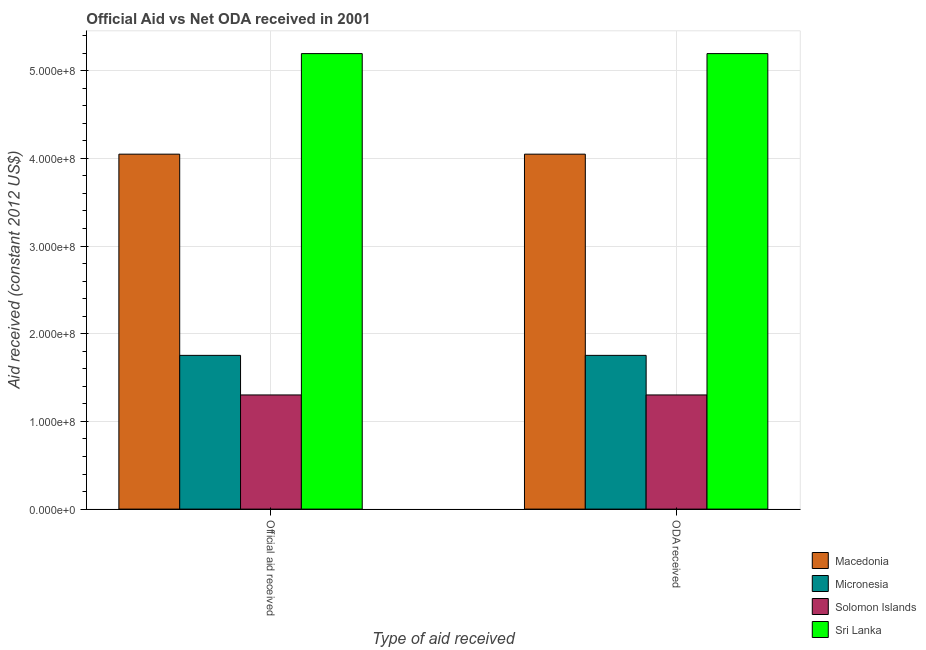How many groups of bars are there?
Your answer should be compact. 2. Are the number of bars per tick equal to the number of legend labels?
Provide a succinct answer. Yes. How many bars are there on the 2nd tick from the left?
Give a very brief answer. 4. What is the label of the 1st group of bars from the left?
Your answer should be very brief. Official aid received. What is the oda received in Solomon Islands?
Make the answer very short. 1.30e+08. Across all countries, what is the maximum official aid received?
Ensure brevity in your answer.  5.20e+08. Across all countries, what is the minimum official aid received?
Ensure brevity in your answer.  1.30e+08. In which country was the oda received maximum?
Provide a short and direct response. Sri Lanka. In which country was the official aid received minimum?
Your response must be concise. Solomon Islands. What is the total oda received in the graph?
Ensure brevity in your answer.  1.23e+09. What is the difference between the official aid received in Solomon Islands and that in Micronesia?
Your response must be concise. -4.52e+07. What is the difference between the oda received in Micronesia and the official aid received in Sri Lanka?
Make the answer very short. -3.44e+08. What is the average oda received per country?
Keep it short and to the point. 3.07e+08. What is the difference between the official aid received and oda received in Micronesia?
Offer a very short reply. 0. In how many countries, is the official aid received greater than 400000000 US$?
Give a very brief answer. 2. What is the ratio of the oda received in Micronesia to that in Macedonia?
Make the answer very short. 0.43. In how many countries, is the official aid received greater than the average official aid received taken over all countries?
Keep it short and to the point. 2. What does the 3rd bar from the left in ODA received represents?
Keep it short and to the point. Solomon Islands. What does the 1st bar from the right in Official aid received represents?
Provide a short and direct response. Sri Lanka. Are all the bars in the graph horizontal?
Your response must be concise. No. How many countries are there in the graph?
Offer a very short reply. 4. What is the difference between two consecutive major ticks on the Y-axis?
Ensure brevity in your answer.  1.00e+08. Does the graph contain any zero values?
Keep it short and to the point. No. Does the graph contain grids?
Offer a terse response. Yes. How many legend labels are there?
Your answer should be very brief. 4. How are the legend labels stacked?
Your response must be concise. Vertical. What is the title of the graph?
Provide a succinct answer. Official Aid vs Net ODA received in 2001 . Does "Georgia" appear as one of the legend labels in the graph?
Give a very brief answer. No. What is the label or title of the X-axis?
Offer a terse response. Type of aid received. What is the label or title of the Y-axis?
Ensure brevity in your answer.  Aid received (constant 2012 US$). What is the Aid received (constant 2012 US$) in Macedonia in Official aid received?
Ensure brevity in your answer.  4.05e+08. What is the Aid received (constant 2012 US$) of Micronesia in Official aid received?
Offer a very short reply. 1.75e+08. What is the Aid received (constant 2012 US$) of Solomon Islands in Official aid received?
Keep it short and to the point. 1.30e+08. What is the Aid received (constant 2012 US$) in Sri Lanka in Official aid received?
Offer a terse response. 5.20e+08. What is the Aid received (constant 2012 US$) of Macedonia in ODA received?
Make the answer very short. 4.05e+08. What is the Aid received (constant 2012 US$) of Micronesia in ODA received?
Offer a terse response. 1.75e+08. What is the Aid received (constant 2012 US$) in Solomon Islands in ODA received?
Ensure brevity in your answer.  1.30e+08. What is the Aid received (constant 2012 US$) of Sri Lanka in ODA received?
Your answer should be very brief. 5.20e+08. Across all Type of aid received, what is the maximum Aid received (constant 2012 US$) in Macedonia?
Offer a very short reply. 4.05e+08. Across all Type of aid received, what is the maximum Aid received (constant 2012 US$) in Micronesia?
Your answer should be very brief. 1.75e+08. Across all Type of aid received, what is the maximum Aid received (constant 2012 US$) in Solomon Islands?
Make the answer very short. 1.30e+08. Across all Type of aid received, what is the maximum Aid received (constant 2012 US$) of Sri Lanka?
Offer a terse response. 5.20e+08. Across all Type of aid received, what is the minimum Aid received (constant 2012 US$) in Macedonia?
Make the answer very short. 4.05e+08. Across all Type of aid received, what is the minimum Aid received (constant 2012 US$) in Micronesia?
Your answer should be very brief. 1.75e+08. Across all Type of aid received, what is the minimum Aid received (constant 2012 US$) in Solomon Islands?
Make the answer very short. 1.30e+08. Across all Type of aid received, what is the minimum Aid received (constant 2012 US$) in Sri Lanka?
Give a very brief answer. 5.20e+08. What is the total Aid received (constant 2012 US$) of Macedonia in the graph?
Ensure brevity in your answer.  8.10e+08. What is the total Aid received (constant 2012 US$) in Micronesia in the graph?
Offer a terse response. 3.51e+08. What is the total Aid received (constant 2012 US$) in Solomon Islands in the graph?
Your answer should be compact. 2.60e+08. What is the total Aid received (constant 2012 US$) of Sri Lanka in the graph?
Ensure brevity in your answer.  1.04e+09. What is the difference between the Aid received (constant 2012 US$) of Micronesia in Official aid received and that in ODA received?
Keep it short and to the point. 0. What is the difference between the Aid received (constant 2012 US$) of Solomon Islands in Official aid received and that in ODA received?
Your response must be concise. 0. What is the difference between the Aid received (constant 2012 US$) of Macedonia in Official aid received and the Aid received (constant 2012 US$) of Micronesia in ODA received?
Ensure brevity in your answer.  2.29e+08. What is the difference between the Aid received (constant 2012 US$) of Macedonia in Official aid received and the Aid received (constant 2012 US$) of Solomon Islands in ODA received?
Offer a terse response. 2.75e+08. What is the difference between the Aid received (constant 2012 US$) in Macedonia in Official aid received and the Aid received (constant 2012 US$) in Sri Lanka in ODA received?
Keep it short and to the point. -1.15e+08. What is the difference between the Aid received (constant 2012 US$) in Micronesia in Official aid received and the Aid received (constant 2012 US$) in Solomon Islands in ODA received?
Your answer should be very brief. 4.52e+07. What is the difference between the Aid received (constant 2012 US$) in Micronesia in Official aid received and the Aid received (constant 2012 US$) in Sri Lanka in ODA received?
Your answer should be very brief. -3.44e+08. What is the difference between the Aid received (constant 2012 US$) of Solomon Islands in Official aid received and the Aid received (constant 2012 US$) of Sri Lanka in ODA received?
Your response must be concise. -3.89e+08. What is the average Aid received (constant 2012 US$) of Macedonia per Type of aid received?
Give a very brief answer. 4.05e+08. What is the average Aid received (constant 2012 US$) in Micronesia per Type of aid received?
Give a very brief answer. 1.75e+08. What is the average Aid received (constant 2012 US$) of Solomon Islands per Type of aid received?
Offer a very short reply. 1.30e+08. What is the average Aid received (constant 2012 US$) in Sri Lanka per Type of aid received?
Provide a short and direct response. 5.20e+08. What is the difference between the Aid received (constant 2012 US$) of Macedonia and Aid received (constant 2012 US$) of Micronesia in Official aid received?
Offer a very short reply. 2.29e+08. What is the difference between the Aid received (constant 2012 US$) of Macedonia and Aid received (constant 2012 US$) of Solomon Islands in Official aid received?
Offer a terse response. 2.75e+08. What is the difference between the Aid received (constant 2012 US$) in Macedonia and Aid received (constant 2012 US$) in Sri Lanka in Official aid received?
Offer a terse response. -1.15e+08. What is the difference between the Aid received (constant 2012 US$) of Micronesia and Aid received (constant 2012 US$) of Solomon Islands in Official aid received?
Offer a terse response. 4.52e+07. What is the difference between the Aid received (constant 2012 US$) in Micronesia and Aid received (constant 2012 US$) in Sri Lanka in Official aid received?
Provide a short and direct response. -3.44e+08. What is the difference between the Aid received (constant 2012 US$) in Solomon Islands and Aid received (constant 2012 US$) in Sri Lanka in Official aid received?
Provide a succinct answer. -3.89e+08. What is the difference between the Aid received (constant 2012 US$) in Macedonia and Aid received (constant 2012 US$) in Micronesia in ODA received?
Provide a succinct answer. 2.29e+08. What is the difference between the Aid received (constant 2012 US$) of Macedonia and Aid received (constant 2012 US$) of Solomon Islands in ODA received?
Provide a short and direct response. 2.75e+08. What is the difference between the Aid received (constant 2012 US$) in Macedonia and Aid received (constant 2012 US$) in Sri Lanka in ODA received?
Give a very brief answer. -1.15e+08. What is the difference between the Aid received (constant 2012 US$) in Micronesia and Aid received (constant 2012 US$) in Solomon Islands in ODA received?
Provide a succinct answer. 4.52e+07. What is the difference between the Aid received (constant 2012 US$) of Micronesia and Aid received (constant 2012 US$) of Sri Lanka in ODA received?
Your answer should be very brief. -3.44e+08. What is the difference between the Aid received (constant 2012 US$) in Solomon Islands and Aid received (constant 2012 US$) in Sri Lanka in ODA received?
Your response must be concise. -3.89e+08. What is the ratio of the Aid received (constant 2012 US$) in Micronesia in Official aid received to that in ODA received?
Your response must be concise. 1. What is the ratio of the Aid received (constant 2012 US$) of Solomon Islands in Official aid received to that in ODA received?
Provide a short and direct response. 1. What is the difference between the highest and the second highest Aid received (constant 2012 US$) in Micronesia?
Make the answer very short. 0. What is the difference between the highest and the second highest Aid received (constant 2012 US$) in Sri Lanka?
Provide a succinct answer. 0. What is the difference between the highest and the lowest Aid received (constant 2012 US$) of Macedonia?
Offer a very short reply. 0. What is the difference between the highest and the lowest Aid received (constant 2012 US$) in Micronesia?
Provide a succinct answer. 0. What is the difference between the highest and the lowest Aid received (constant 2012 US$) in Solomon Islands?
Your response must be concise. 0. What is the difference between the highest and the lowest Aid received (constant 2012 US$) of Sri Lanka?
Your answer should be compact. 0. 